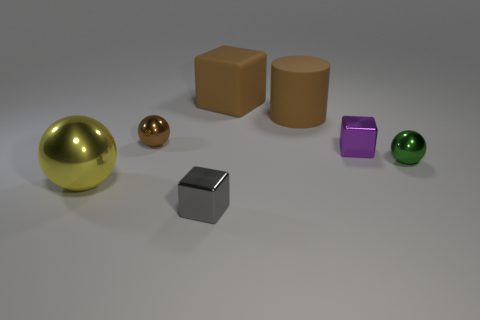Add 2 rubber things. How many objects exist? 9 Subtract all blocks. How many objects are left? 4 Add 4 brown cylinders. How many brown cylinders are left? 5 Add 2 cylinders. How many cylinders exist? 3 Subtract 1 green balls. How many objects are left? 6 Subtract all tiny metal cubes. Subtract all blocks. How many objects are left? 2 